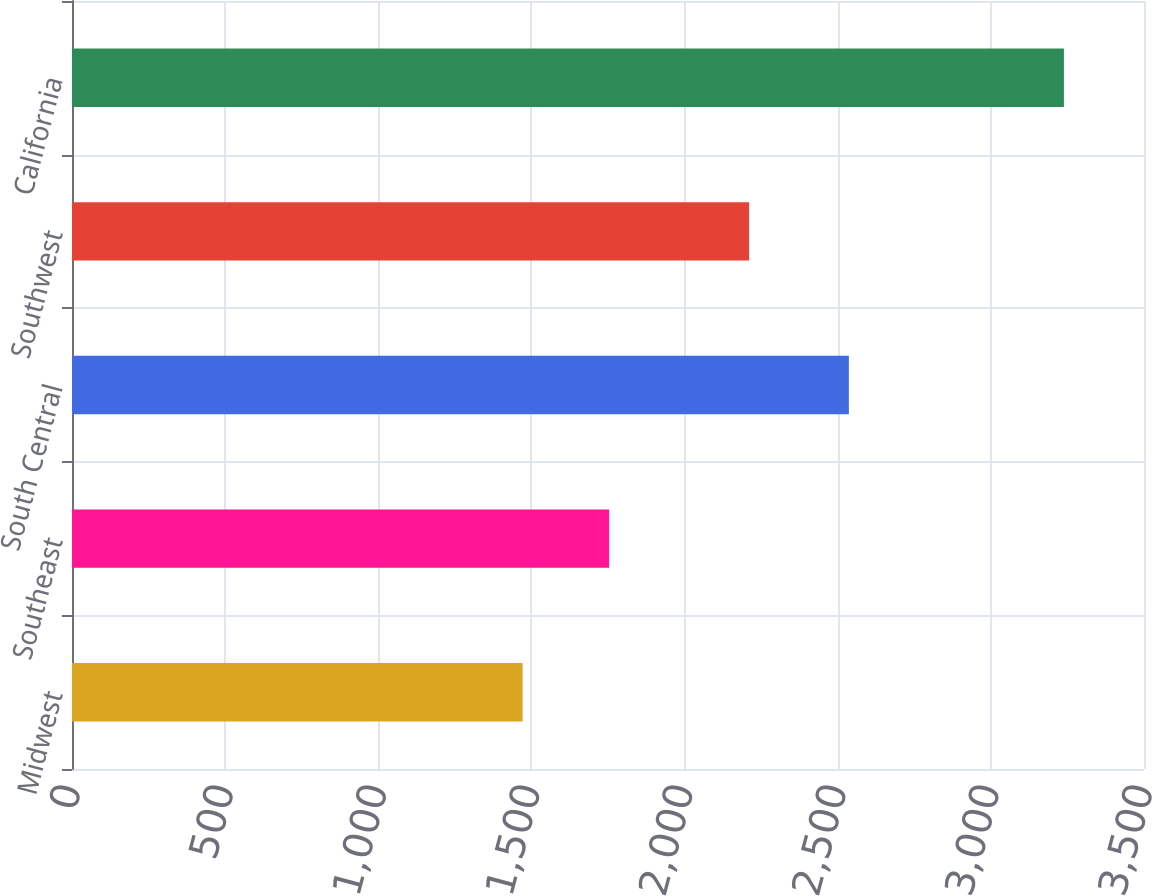Convert chart. <chart><loc_0><loc_0><loc_500><loc_500><bar_chart><fcel>Midwest<fcel>Southeast<fcel>South Central<fcel>Southwest<fcel>California<nl><fcel>1471.3<fcel>1753.8<fcel>2536.4<fcel>2210.8<fcel>3238.6<nl></chart> 